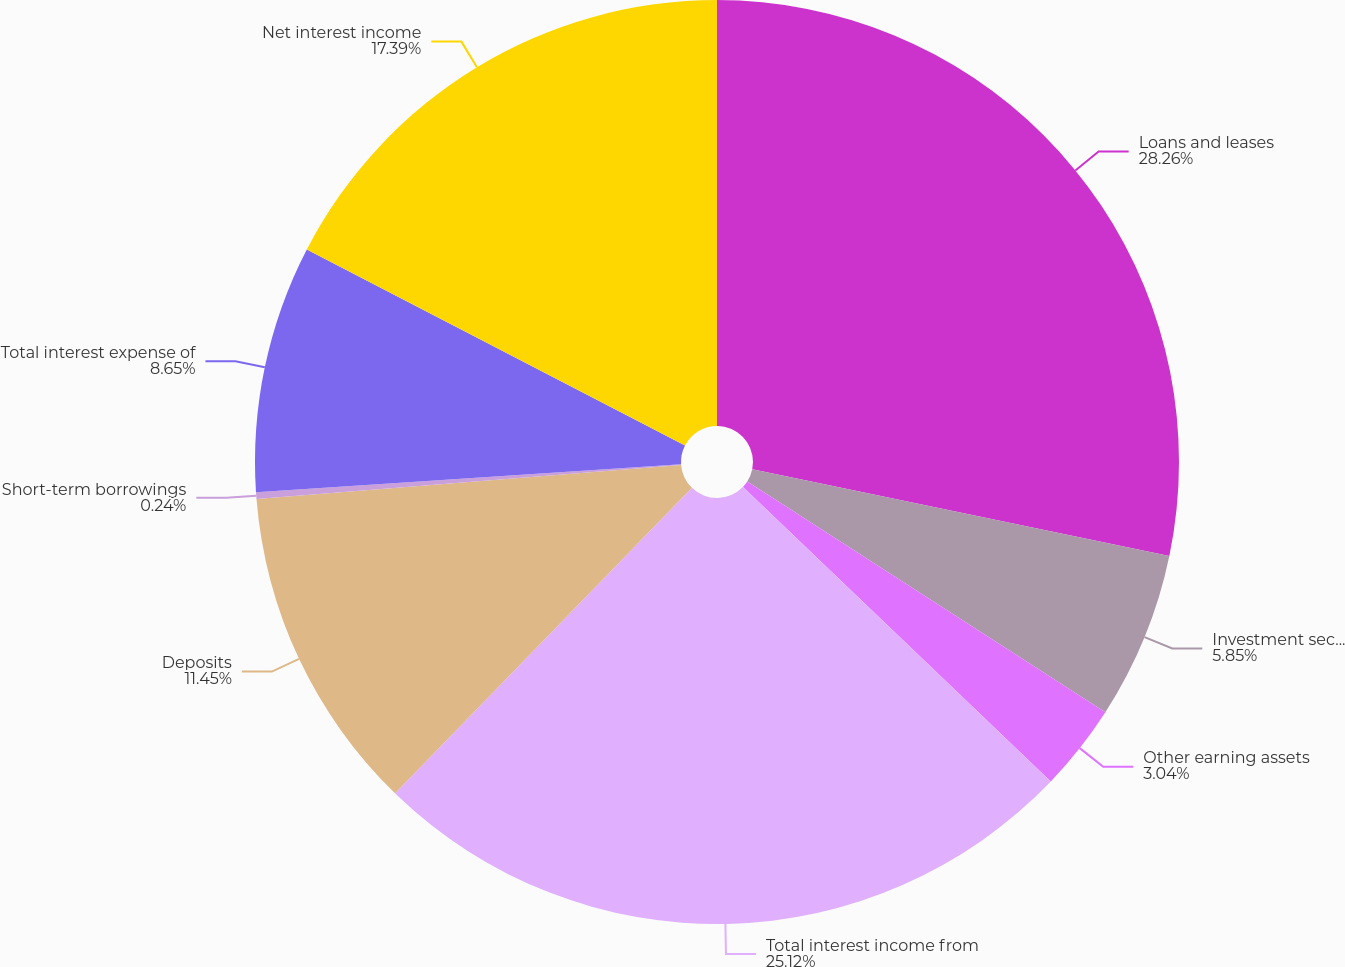Convert chart. <chart><loc_0><loc_0><loc_500><loc_500><pie_chart><fcel>Loans and leases<fcel>Investment securities<fcel>Other earning assets<fcel>Total interest income from<fcel>Deposits<fcel>Short-term borrowings<fcel>Total interest expense of<fcel>Net interest income<nl><fcel>28.26%<fcel>5.85%<fcel>3.04%<fcel>25.12%<fcel>11.45%<fcel>0.24%<fcel>8.65%<fcel>17.39%<nl></chart> 